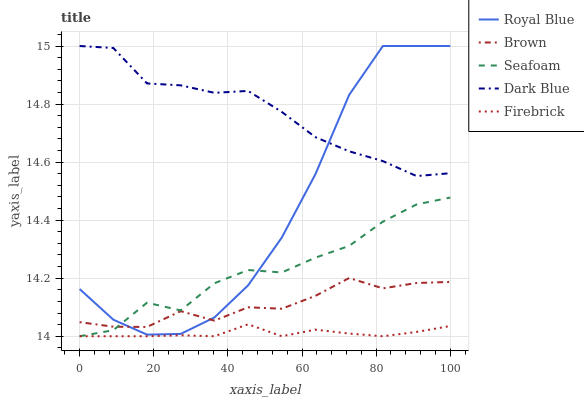Does Firebrick have the minimum area under the curve?
Answer yes or no. Yes. Does Dark Blue have the minimum area under the curve?
Answer yes or no. No. Does Firebrick have the maximum area under the curve?
Answer yes or no. No. Is Dark Blue the smoothest?
Answer yes or no. No. Is Dark Blue the roughest?
Answer yes or no. No. Does Dark Blue have the lowest value?
Answer yes or no. No. Does Firebrick have the highest value?
Answer yes or no. No. Is Brown less than Dark Blue?
Answer yes or no. Yes. Is Royal Blue greater than Firebrick?
Answer yes or no. Yes. Does Brown intersect Dark Blue?
Answer yes or no. No. 